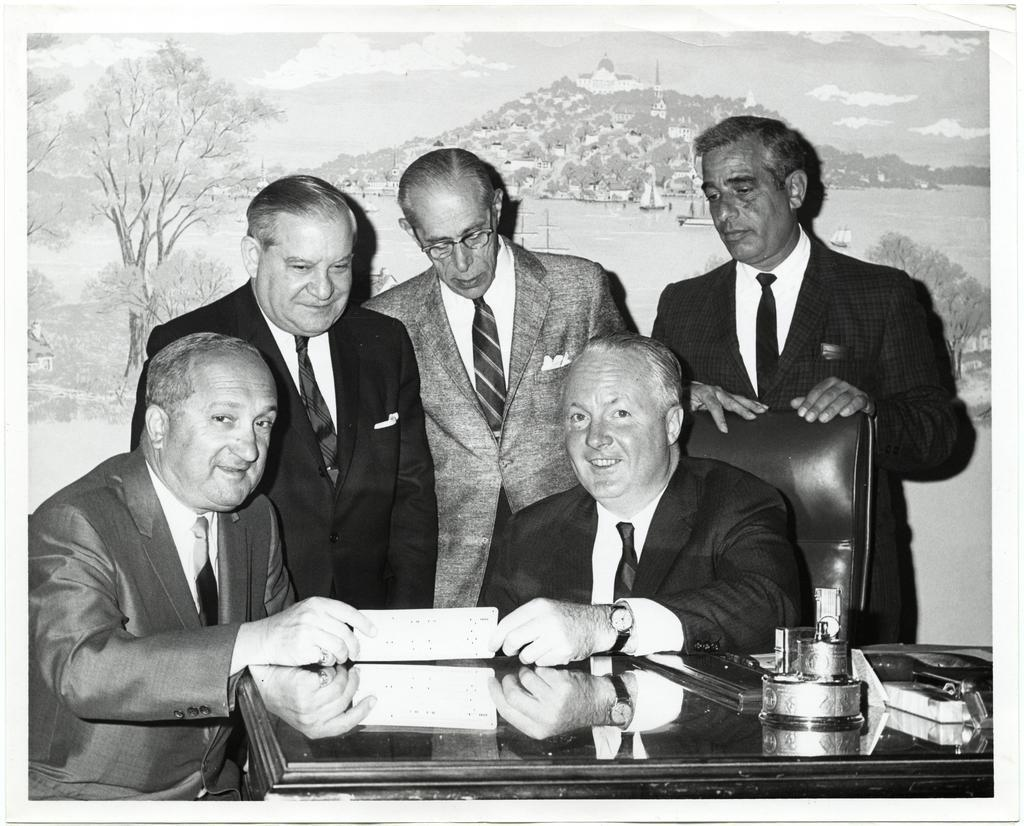What is the color scheme of the image? The image is black and white. How many people are sitting at the table in the image? There are many persons sitting at the table. What can be found on the table besides the people? There are objects on the table, including a book. What is visible in the background of the image? There is a painting in the background. What type of argument is taking place between the band members in the image? There is no band or argument present in the image; it features a black and white scene with people sitting at a table and a painting in the background. What kind of root is growing through the table in the image? There is no root visible in the image; it only shows a table with objects and people sitting at it. 